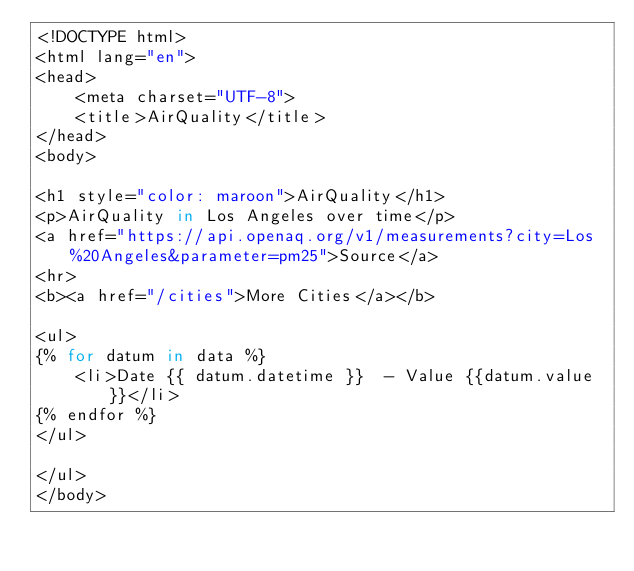<code> <loc_0><loc_0><loc_500><loc_500><_Python_><!DOCTYPE html>
<html lang="en">
<head>
    <meta charset="UTF-8">
    <title>AirQuality</title>
</head>
<body>

<h1 style="color: maroon">AirQuality</h1>
<p>AirQuality in Los Angeles over time</p>
<a href="https://api.openaq.org/v1/measurements?city=Los%20Angeles&parameter=pm25">Source</a>
<hr>
<b><a href="/cities">More Cities</a></b>

<ul>
{% for datum in data %}
    <li>Date {{ datum.datetime }}  - Value {{datum.value}}</li>
{% endfor %}
</ul>

</ul>
</body>
</code> 